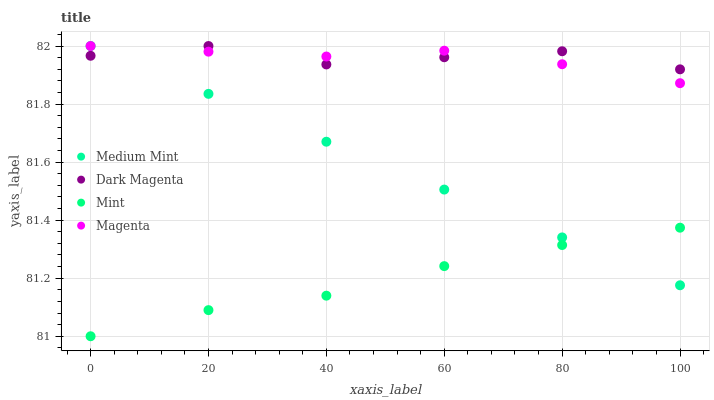Does Mint have the minimum area under the curve?
Answer yes or no. Yes. Does Dark Magenta have the maximum area under the curve?
Answer yes or no. Yes. Does Magenta have the minimum area under the curve?
Answer yes or no. No. Does Magenta have the maximum area under the curve?
Answer yes or no. No. Is Medium Mint the smoothest?
Answer yes or no. Yes. Is Dark Magenta the roughest?
Answer yes or no. Yes. Is Magenta the smoothest?
Answer yes or no. No. Is Magenta the roughest?
Answer yes or no. No. Does Mint have the lowest value?
Answer yes or no. Yes. Does Magenta have the lowest value?
Answer yes or no. No. Does Dark Magenta have the highest value?
Answer yes or no. Yes. Does Mint have the highest value?
Answer yes or no. No. Is Mint less than Magenta?
Answer yes or no. Yes. Is Dark Magenta greater than Mint?
Answer yes or no. Yes. Does Medium Mint intersect Magenta?
Answer yes or no. Yes. Is Medium Mint less than Magenta?
Answer yes or no. No. Is Medium Mint greater than Magenta?
Answer yes or no. No. Does Mint intersect Magenta?
Answer yes or no. No. 